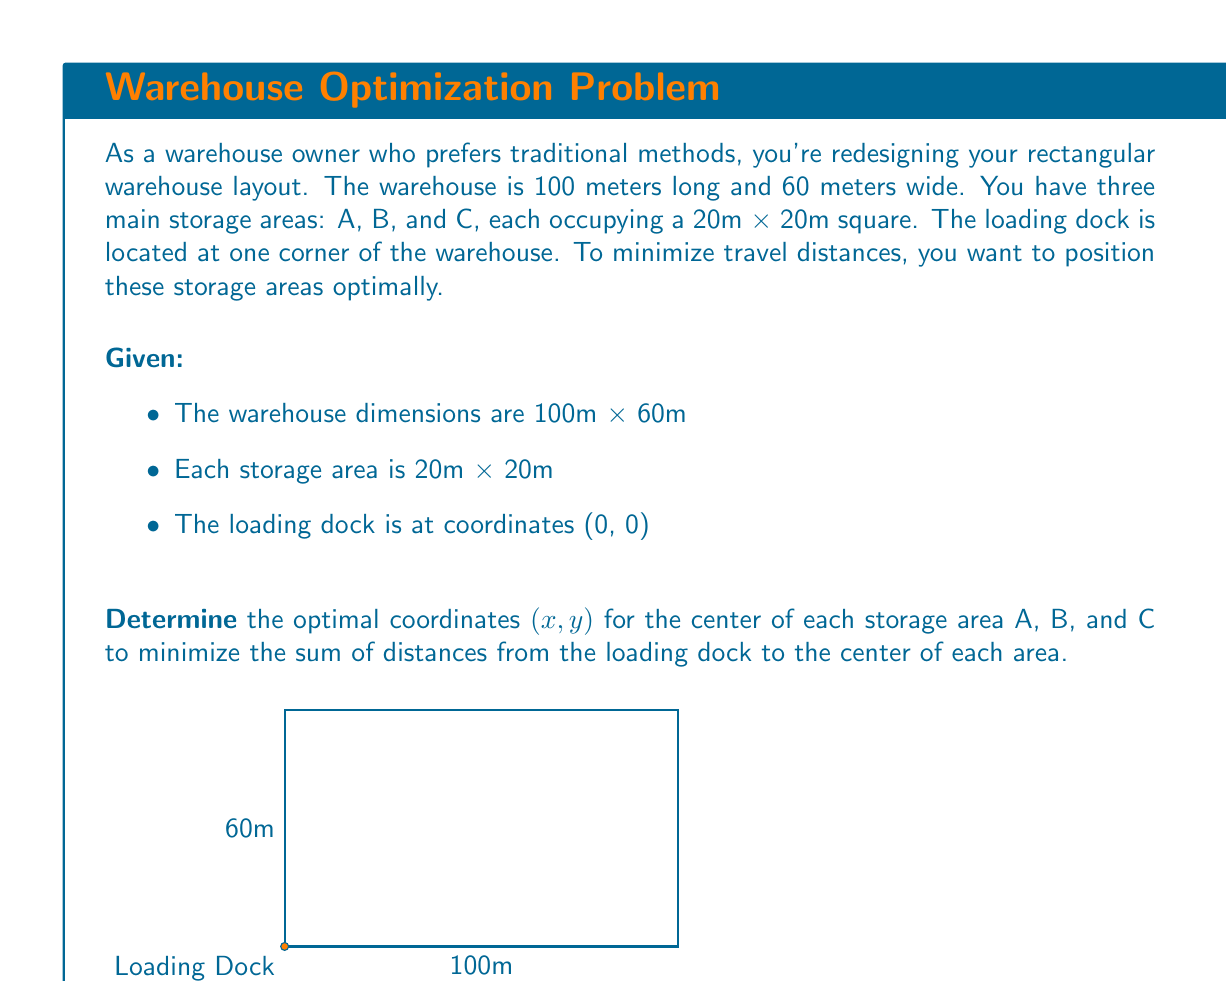Show me your answer to this math problem. Let's approach this step-by-step:

1) To minimize travel distances, we want to place the storage areas as close to the loading dock as possible while maintaining efficient use of space.

2) The optimal arrangement will be to place the storage areas in a diagonal line from the loading dock corner.

3) Given that each storage area is 20m x 20m, the center of the first area (A) should be 10m from each edge:
   $A: (x_A, y_A) = (10, 10)$

4) The second area (B) should be placed next to A, with its center 30m from one edge and 10m from the other:
   $B: (x_B, y_B) = (30, 30)$

5) The third area (C) follows the same pattern:
   $C: (x_C, y_C) = (50, 50)$

6) To verify this is optimal, we can calculate the sum of distances from the loading dock to each center:

   Distance to A: $\sqrt{10^2 + 10^2} = 10\sqrt{2}$
   Distance to B: $\sqrt{30^2 + 30^2} = 30\sqrt{2}$
   Distance to C: $\sqrt{50^2 + 50^2} = 50\sqrt{2}$

   Total distance: $10\sqrt{2} + 30\sqrt{2} + 50\sqrt{2} = 90\sqrt{2}$

7) Any other arrangement would increase this total distance, as moving any storage area further from the diagonal line would increase its distance from the loading dock more than it would decrease the distance of another area.
Answer: $A(10, 10)$, $B(30, 30)$, $C(50, 50)$ 